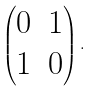<formula> <loc_0><loc_0><loc_500><loc_500>\left ( \begin{matrix} 0 & 1 \\ 1 & 0 \end{matrix} \right ) .</formula> 